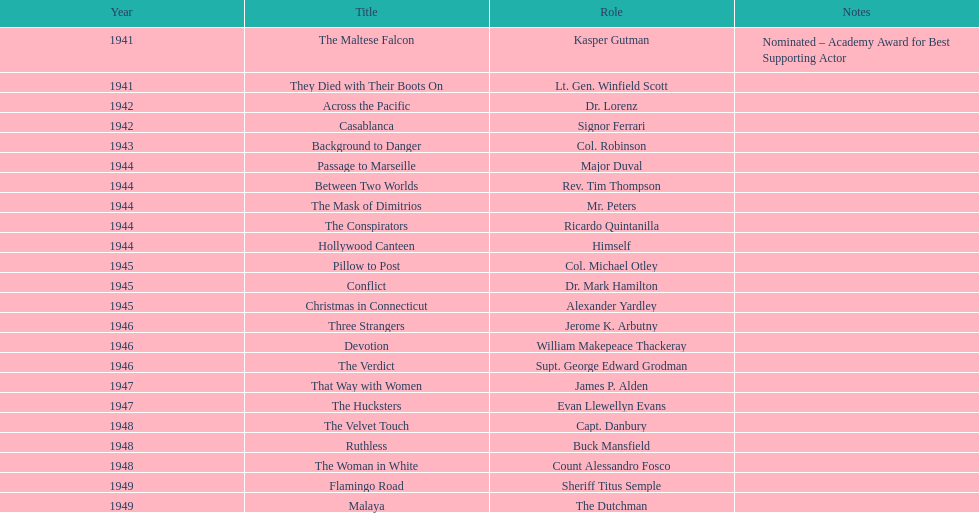How many movies has he been from 1941-1949. 23. 